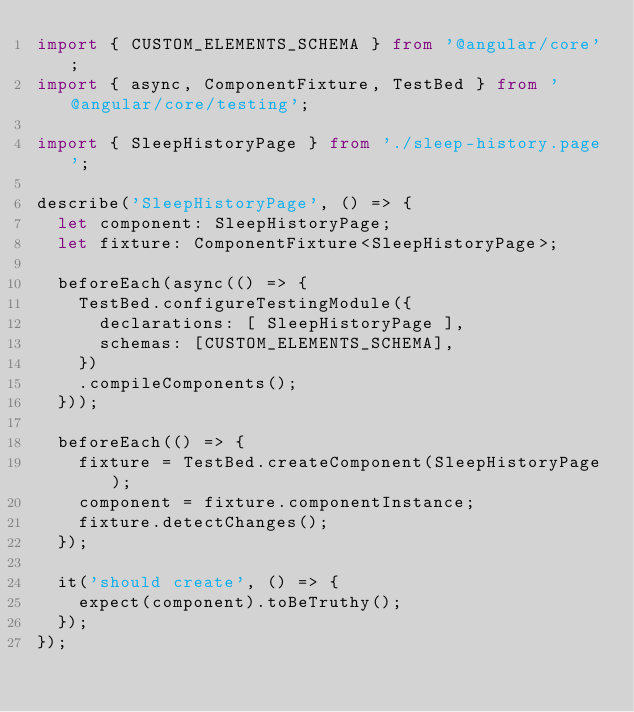Convert code to text. <code><loc_0><loc_0><loc_500><loc_500><_TypeScript_>import { CUSTOM_ELEMENTS_SCHEMA } from '@angular/core';
import { async, ComponentFixture, TestBed } from '@angular/core/testing';

import { SleepHistoryPage } from './sleep-history.page';

describe('SleepHistoryPage', () => {
  let component: SleepHistoryPage;
  let fixture: ComponentFixture<SleepHistoryPage>;

  beforeEach(async(() => {
    TestBed.configureTestingModule({
      declarations: [ SleepHistoryPage ],
      schemas: [CUSTOM_ELEMENTS_SCHEMA],
    })
    .compileComponents();
  }));

  beforeEach(() => {
    fixture = TestBed.createComponent(SleepHistoryPage);
    component = fixture.componentInstance;
    fixture.detectChanges();
  });

  it('should create', () => {
    expect(component).toBeTruthy();
  });
});
</code> 